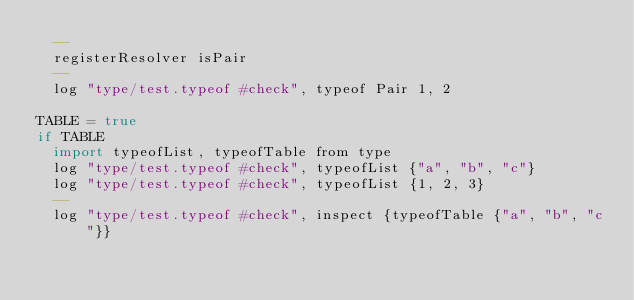Convert code to text. <code><loc_0><loc_0><loc_500><loc_500><_MoonScript_>  --
  registerResolver isPair
  --
  log "type/test.typeof #check", typeof Pair 1, 2

TABLE = true
if TABLE
  import typeofList, typeofTable from type
  log "type/test.typeof #check", typeofList {"a", "b", "c"}
  log "type/test.typeof #check", typeofList {1, 2, 3}
  --
  log "type/test.typeof #check", inspect {typeofTable {"a", "b", "c"}}</code> 